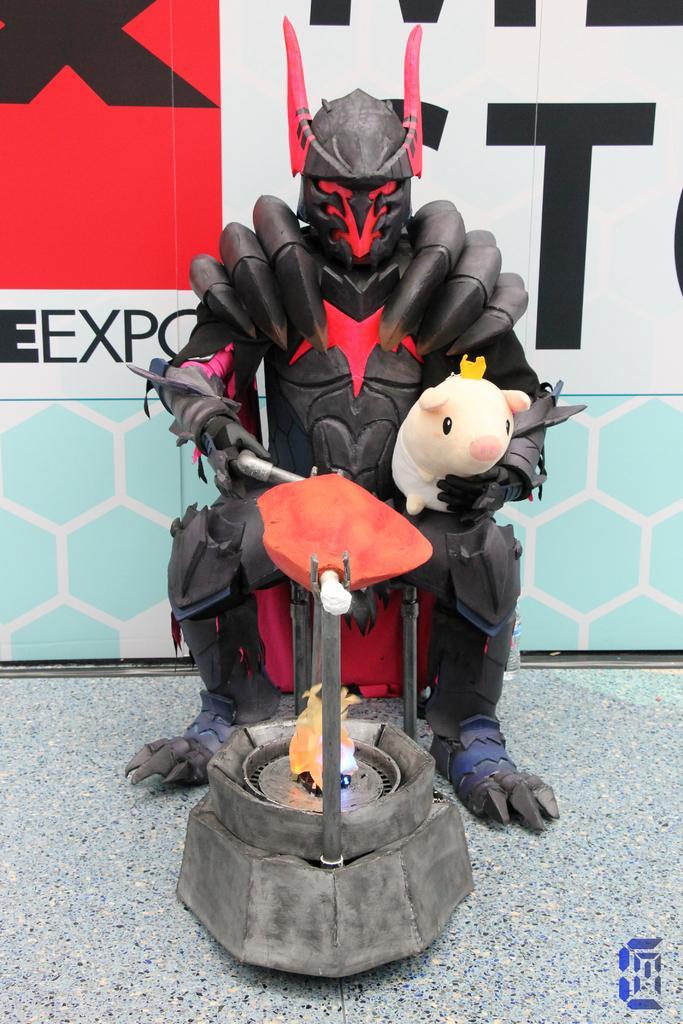Could you give a brief overview of what you see in this image? This image is taken outdoors. At the bottom of the image there is a floor. In the background there is a board with a text on it. In the middle of the image there is an artificial stove and there is a toy and there is a piggy bank. 